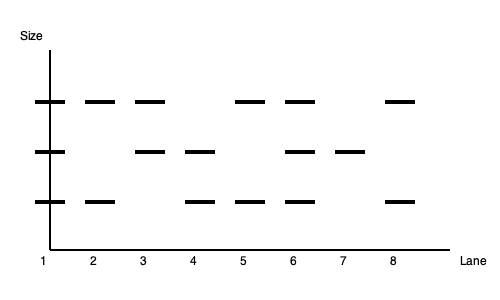Analyze the DNA profile electrophoresis results shown in the image. Which lane(s) could potentially belong to the suspect if the crime scene sample is represented by Lane 6? To determine which lane(s) could potentially belong to the suspect, we need to follow these steps:

1. Identify the crime scene sample: Lane 6 represents the crime scene sample.

2. Analyze Lane 6 pattern:
   - It shows bands at three positions (top, middle, and bottom).

3. Compare other lanes to Lane 6:
   - We're looking for lanes that have all the bands present in Lane 6, but may also have additional bands.
   - This is because the suspect's DNA should contain all the alleles found at the crime scene, but may have additional alleles not deposited at the scene.

4. Evaluate each lane:
   - Lane 1: Matches all bands in Lane 6. Potential match.
   - Lane 2: Missing middle band. Not a match.
   - Lane 3: Missing bottom band. Not a match.
   - Lane 4: Missing top band. Not a match.
   - Lane 5: Missing middle band. Not a match.
   - Lane 6: Crime scene sample (reference).
   - Lane 7: Missing top band. Not a match.
   - Lane 8: Missing middle band. Not a match.

5. Conclusion:
   - Only Lane 1 contains all the bands present in the crime scene sample (Lane 6).

Therefore, based on this DNA profile, only Lane 1 could potentially belong to the suspect.
Answer: Lane 1 